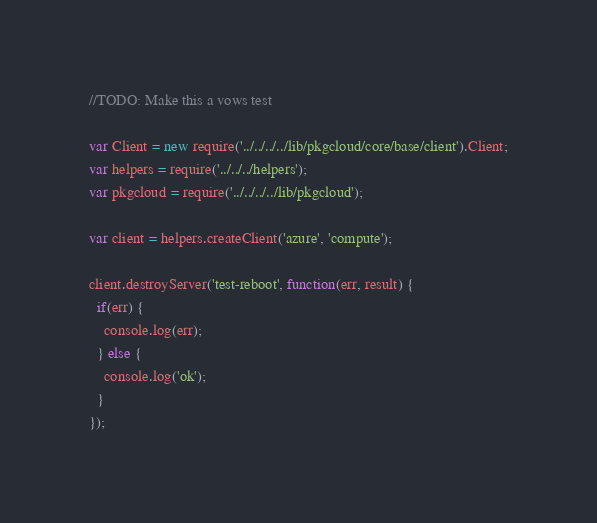Convert code to text. <code><loc_0><loc_0><loc_500><loc_500><_JavaScript_>//TODO: Make this a vows test

var Client = new require('../../../../lib/pkgcloud/core/base/client').Client;
var helpers = require('../../../helpers');
var pkgcloud = require('../../../../lib/pkgcloud');

var client = helpers.createClient('azure', 'compute');

client.destroyServer('test-reboot', function(err, result) {
  if(err) {
    console.log(err);
  } else {
    console.log('ok');
  }
});




</code> 